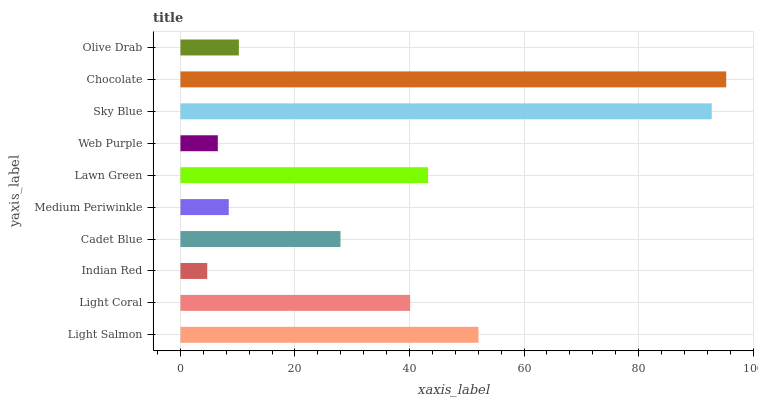Is Indian Red the minimum?
Answer yes or no. Yes. Is Chocolate the maximum?
Answer yes or no. Yes. Is Light Coral the minimum?
Answer yes or no. No. Is Light Coral the maximum?
Answer yes or no. No. Is Light Salmon greater than Light Coral?
Answer yes or no. Yes. Is Light Coral less than Light Salmon?
Answer yes or no. Yes. Is Light Coral greater than Light Salmon?
Answer yes or no. No. Is Light Salmon less than Light Coral?
Answer yes or no. No. Is Light Coral the high median?
Answer yes or no. Yes. Is Cadet Blue the low median?
Answer yes or no. Yes. Is Indian Red the high median?
Answer yes or no. No. Is Web Purple the low median?
Answer yes or no. No. 